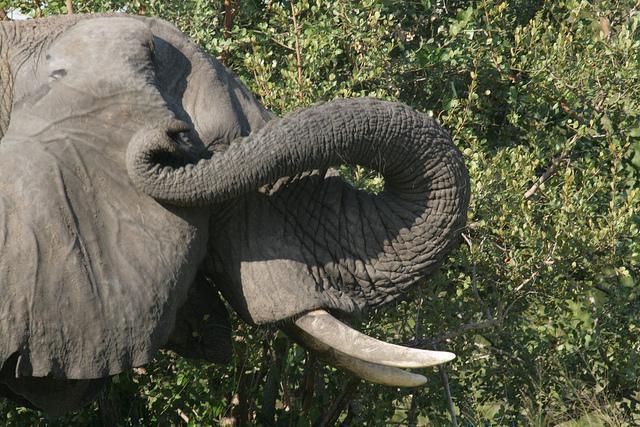How many people are in present?
Give a very brief answer. 0. 